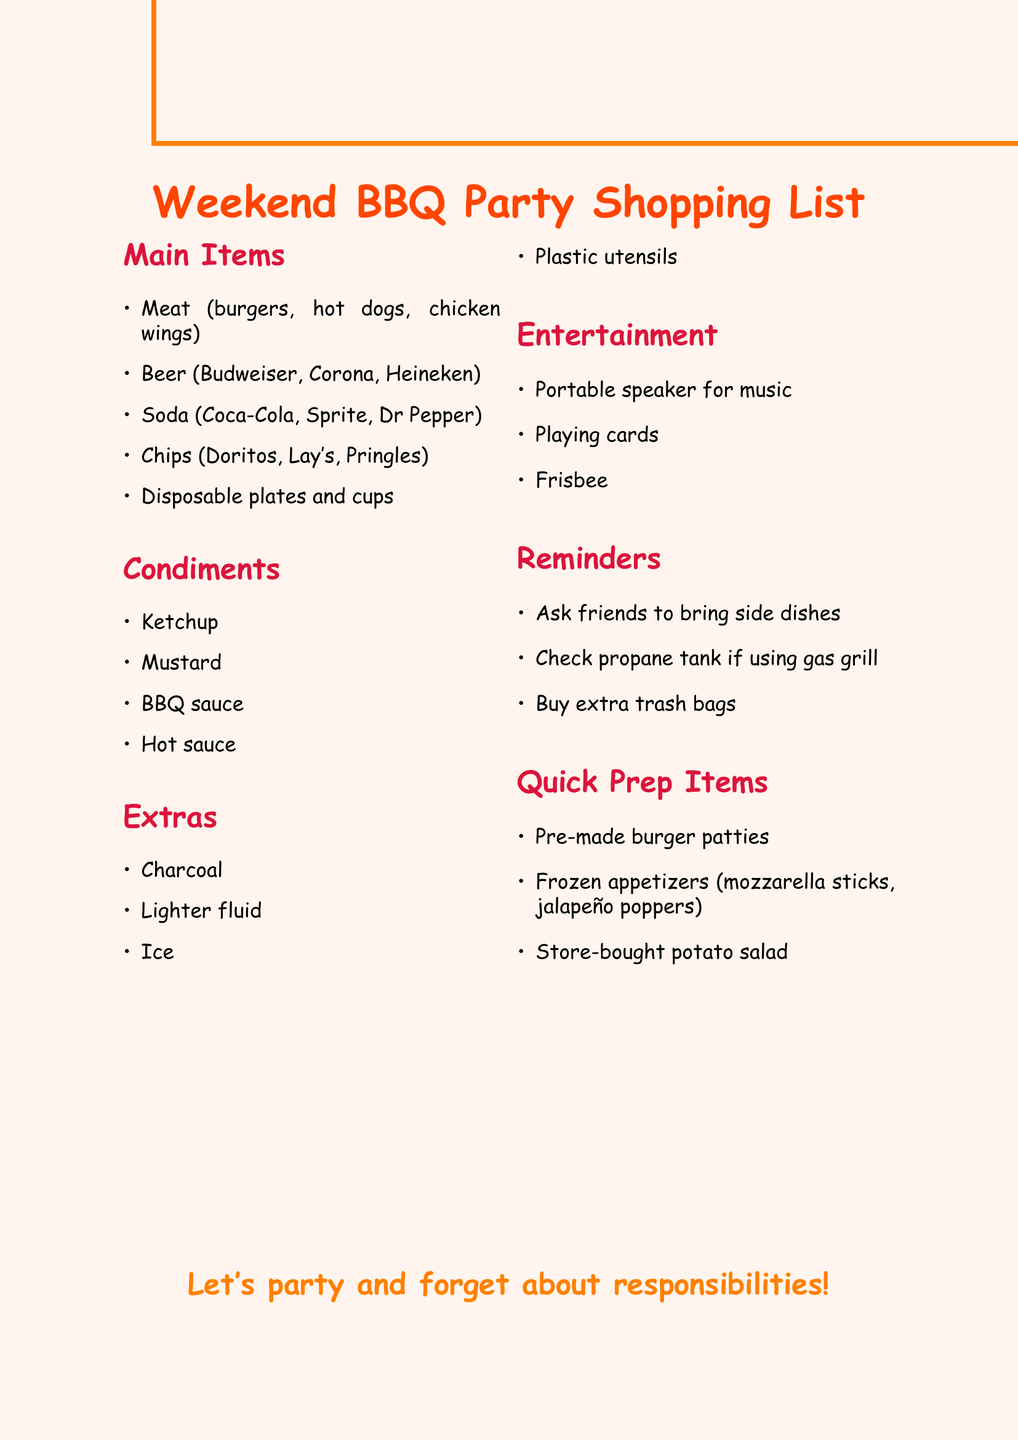What are the main items listed for the BBQ? The main items are specifically mentioned in their section and include things commonly used for BBQs.
Answer: Meat, Beer, Soda, Chips, Disposable plates and cups How many types of condiments are included? The document explicitly lists condiments under their own section, allowing for a straightforward count of items.
Answer: 4 What is one of the extras needed for the BBQ? The document outlines extra items needed and lists several essential supplies, including fuel for grilling.
Answer: Charcoal What kind of entertainment is suggested? Entertainment items are listed in their designated section and represent options for social activities during the BBQ.
Answer: Portable speaker for music What are the quick prep items mentioned? The quick prep items consist of easily prepared or ready-made food items, which are explicitly listed.
Answer: Pre-made burger patties, Frozen appetizers, Store-bought potato salad What reminder is given about side dishes? The reminders section contains specific actions to take before the BBQ, including coordination with friends regarding food.
Answer: Ask friends to bring side dishes Which beverage brands are suggested? The beverage brands are specified under the main items for the BBQ, indicating popular choices.
Answer: Budweiser, Corona, Heineken What cooking fuel should be checked? This information can be found in the reminders section, suggesting an important preparatory step for the BBQ.
Answer: Propane tank 